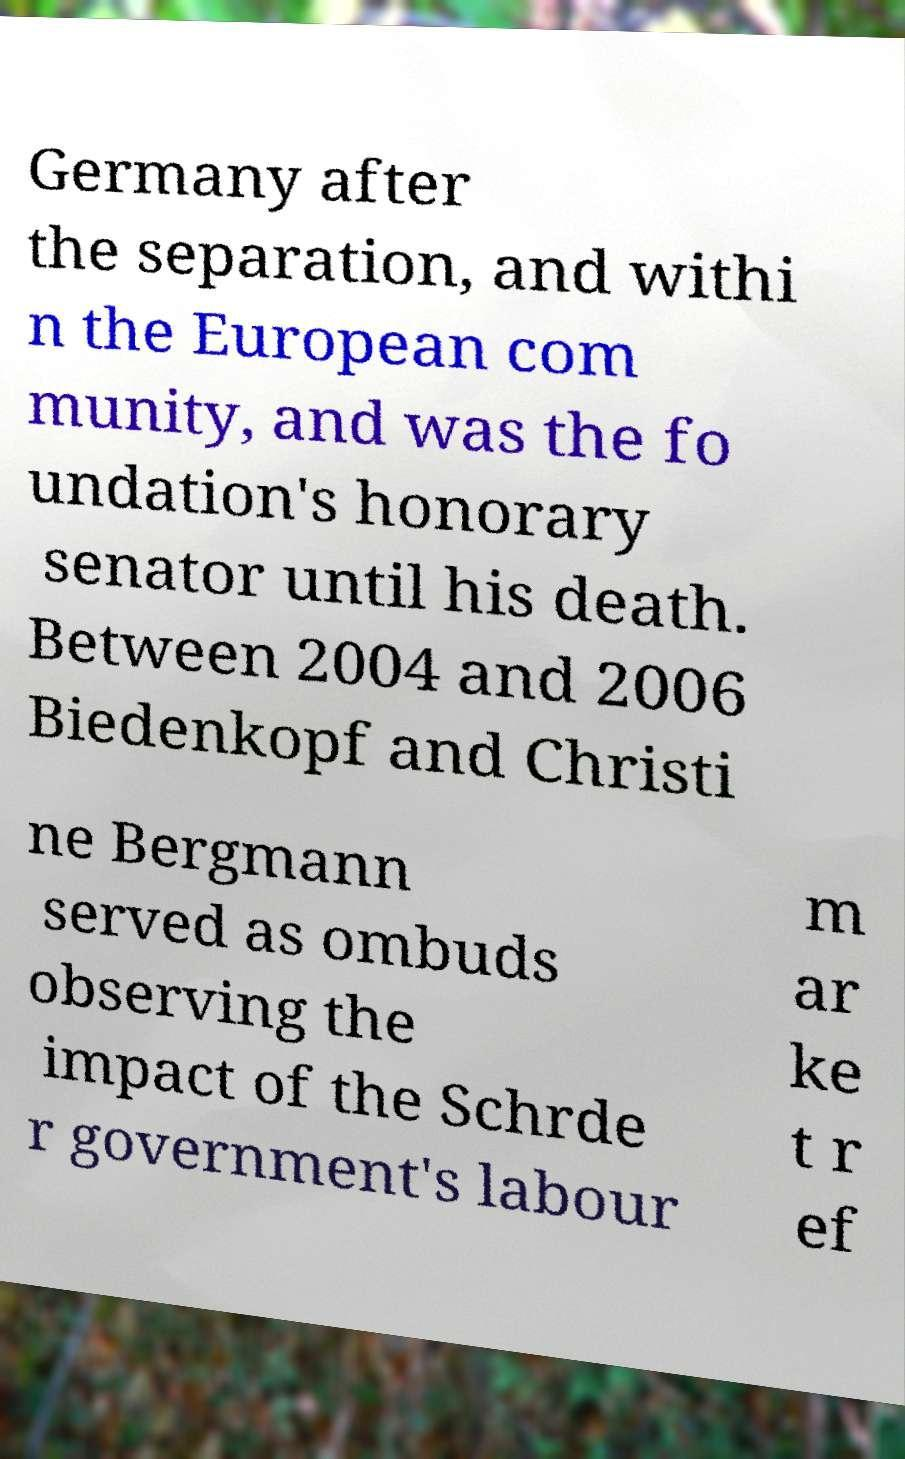Could you assist in decoding the text presented in this image and type it out clearly? Germany after the separation, and withi n the European com munity, and was the fo undation's honorary senator until his death. Between 2004 and 2006 Biedenkopf and Christi ne Bergmann served as ombuds observing the impact of the Schrde r government's labour m ar ke t r ef 